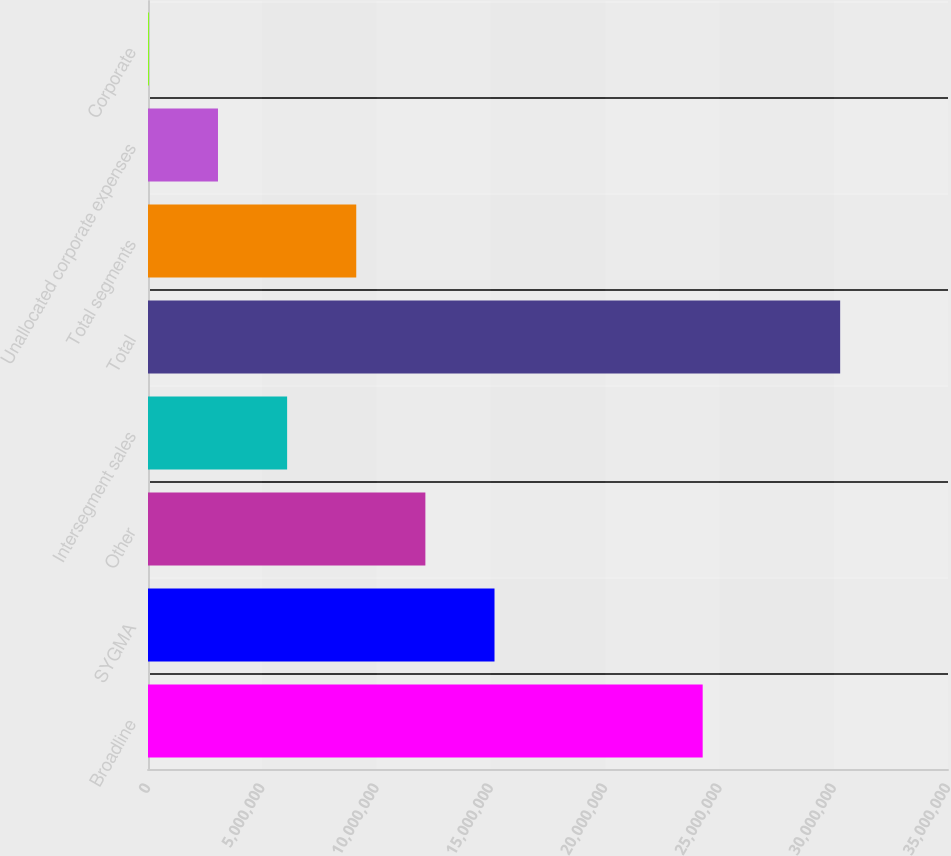<chart> <loc_0><loc_0><loc_500><loc_500><bar_chart><fcel>Broadline<fcel>SYGMA<fcel>Other<fcel>Intersegment sales<fcel>Total<fcel>Total segments<fcel>Unallocated corporate expenses<fcel>Corporate<nl><fcel>2.4267e+07<fcel>1.51597e+07<fcel>1.21353e+07<fcel>6.08642e+06<fcel>3.02819e+07<fcel>9.11085e+06<fcel>3.06198e+06<fcel>37543<nl></chart> 